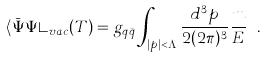<formula> <loc_0><loc_0><loc_500><loc_500>\langle { \bar { \Psi } } \Psi \rangle _ { v a c } ( T ) = g _ { q { \bar { q } } } \int _ { | p | < \Lambda } \frac { d ^ { 3 } p } { 2 ( 2 \pi ) ^ { 3 } } \frac { m } { E } \ .</formula> 